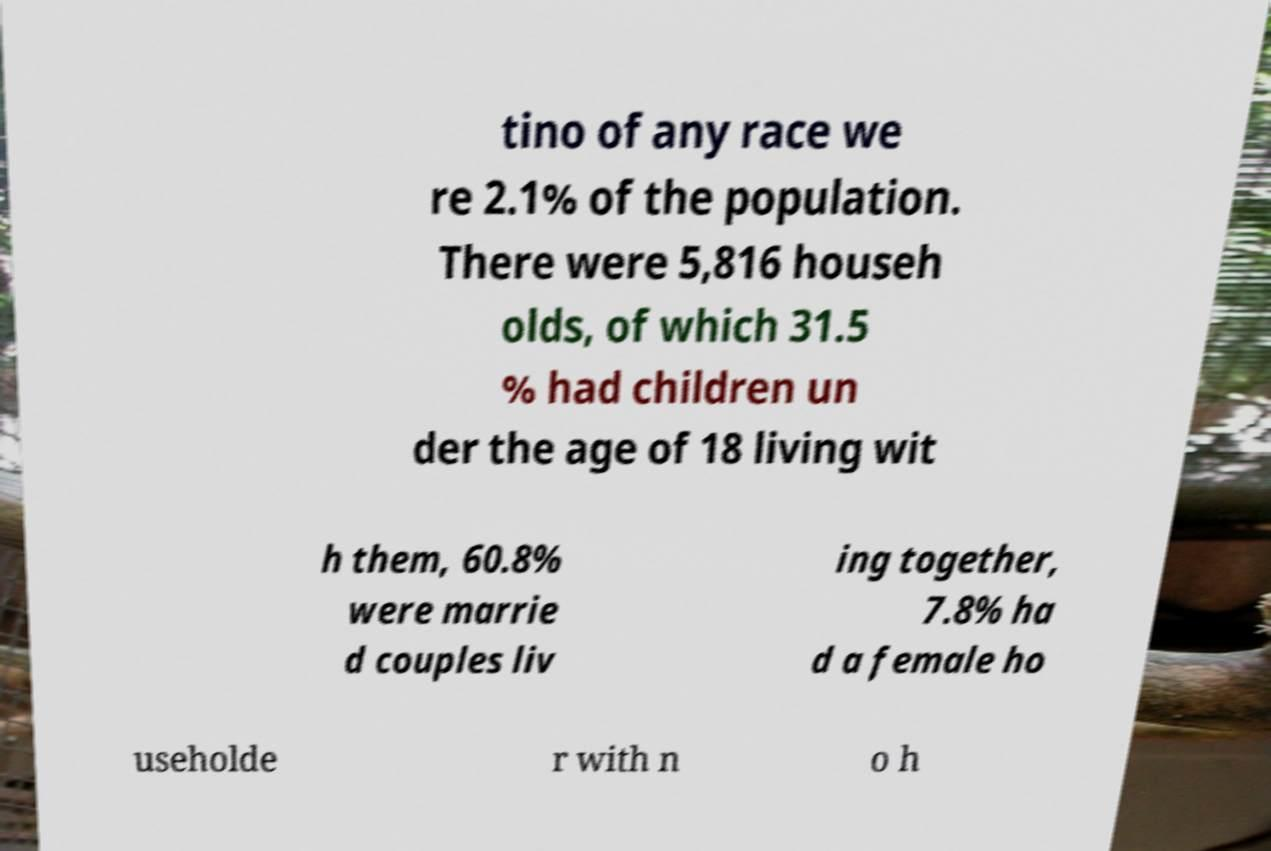I need the written content from this picture converted into text. Can you do that? tino of any race we re 2.1% of the population. There were 5,816 househ olds, of which 31.5 % had children un der the age of 18 living wit h them, 60.8% were marrie d couples liv ing together, 7.8% ha d a female ho useholde r with n o h 